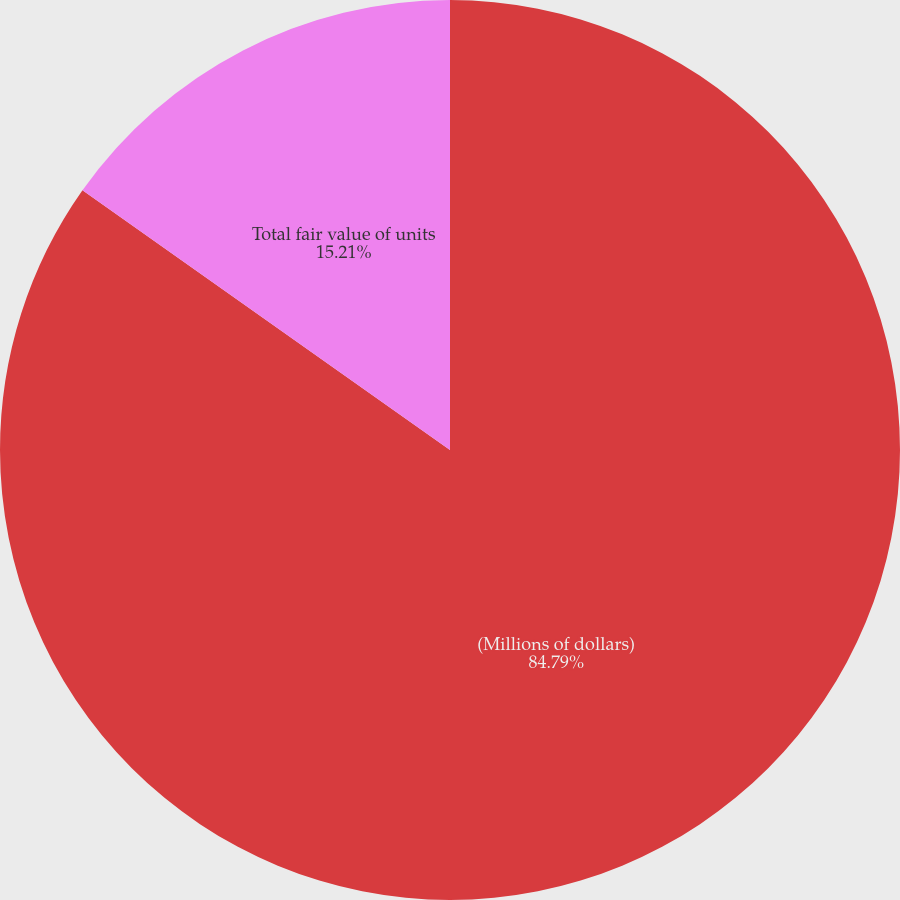Convert chart. <chart><loc_0><loc_0><loc_500><loc_500><pie_chart><fcel>(Millions of dollars)<fcel>Total fair value of units<nl><fcel>84.79%<fcel>15.21%<nl></chart> 